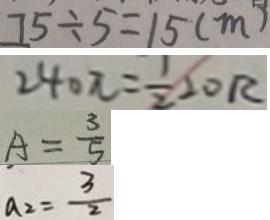Convert formula to latex. <formula><loc_0><loc_0><loc_500><loc_500>7 5 \div 5 = 1 5 ( m ) 
 2 4 0 \pi = \frac { 1 } { 2 } 2 0 R 
 A = \frac { 3 } { 5 } 
 a _ { 2 } = \frac { 3 } { 2 }</formula> 